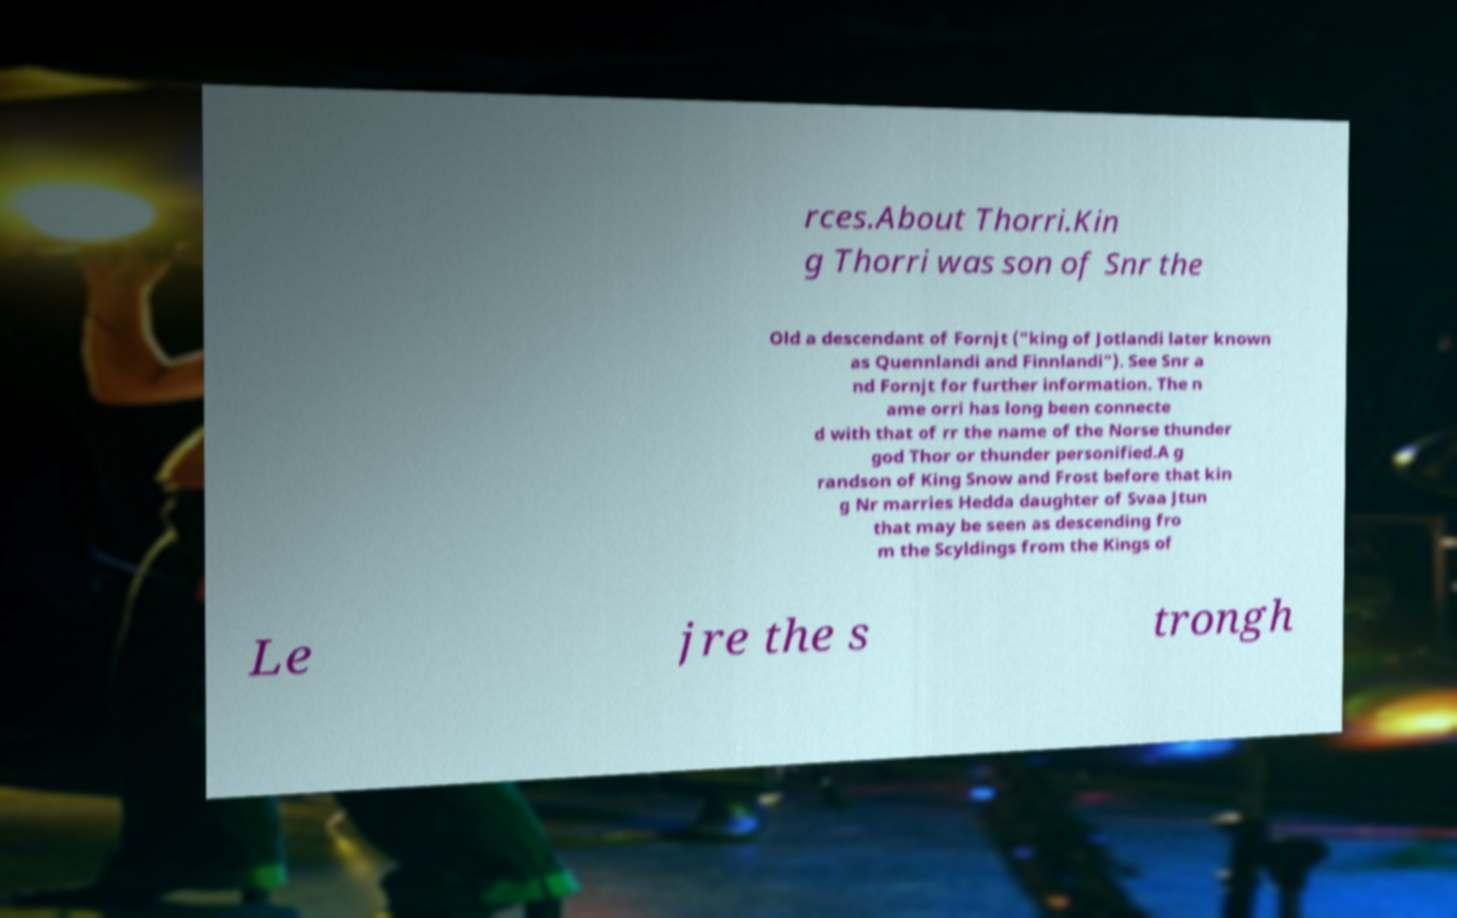What messages or text are displayed in this image? I need them in a readable, typed format. rces.About Thorri.Kin g Thorri was son of Snr the Old a descendant of Fornjt ("king of Jotlandi later known as Quennlandi and Finnlandi"). See Snr a nd Fornjt for further information. The n ame orri has long been connecte d with that of rr the name of the Norse thunder god Thor or thunder personified.A g randson of King Snow and Frost before that kin g Nr marries Hedda daughter of Svaa Jtun that may be seen as descending fro m the Scyldings from the Kings of Le jre the s trongh 